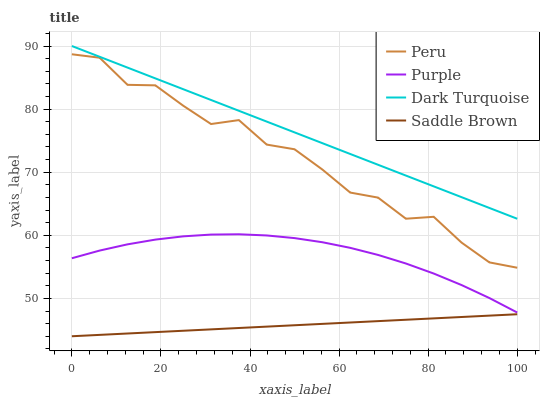Does Saddle Brown have the minimum area under the curve?
Answer yes or no. Yes. Does Dark Turquoise have the maximum area under the curve?
Answer yes or no. Yes. Does Dark Turquoise have the minimum area under the curve?
Answer yes or no. No. Does Saddle Brown have the maximum area under the curve?
Answer yes or no. No. Is Saddle Brown the smoothest?
Answer yes or no. Yes. Is Peru the roughest?
Answer yes or no. Yes. Is Dark Turquoise the smoothest?
Answer yes or no. No. Is Dark Turquoise the roughest?
Answer yes or no. No. Does Saddle Brown have the lowest value?
Answer yes or no. Yes. Does Dark Turquoise have the lowest value?
Answer yes or no. No. Does Dark Turquoise have the highest value?
Answer yes or no. Yes. Does Saddle Brown have the highest value?
Answer yes or no. No. Is Peru less than Dark Turquoise?
Answer yes or no. Yes. Is Peru greater than Purple?
Answer yes or no. Yes. Does Peru intersect Dark Turquoise?
Answer yes or no. No. 